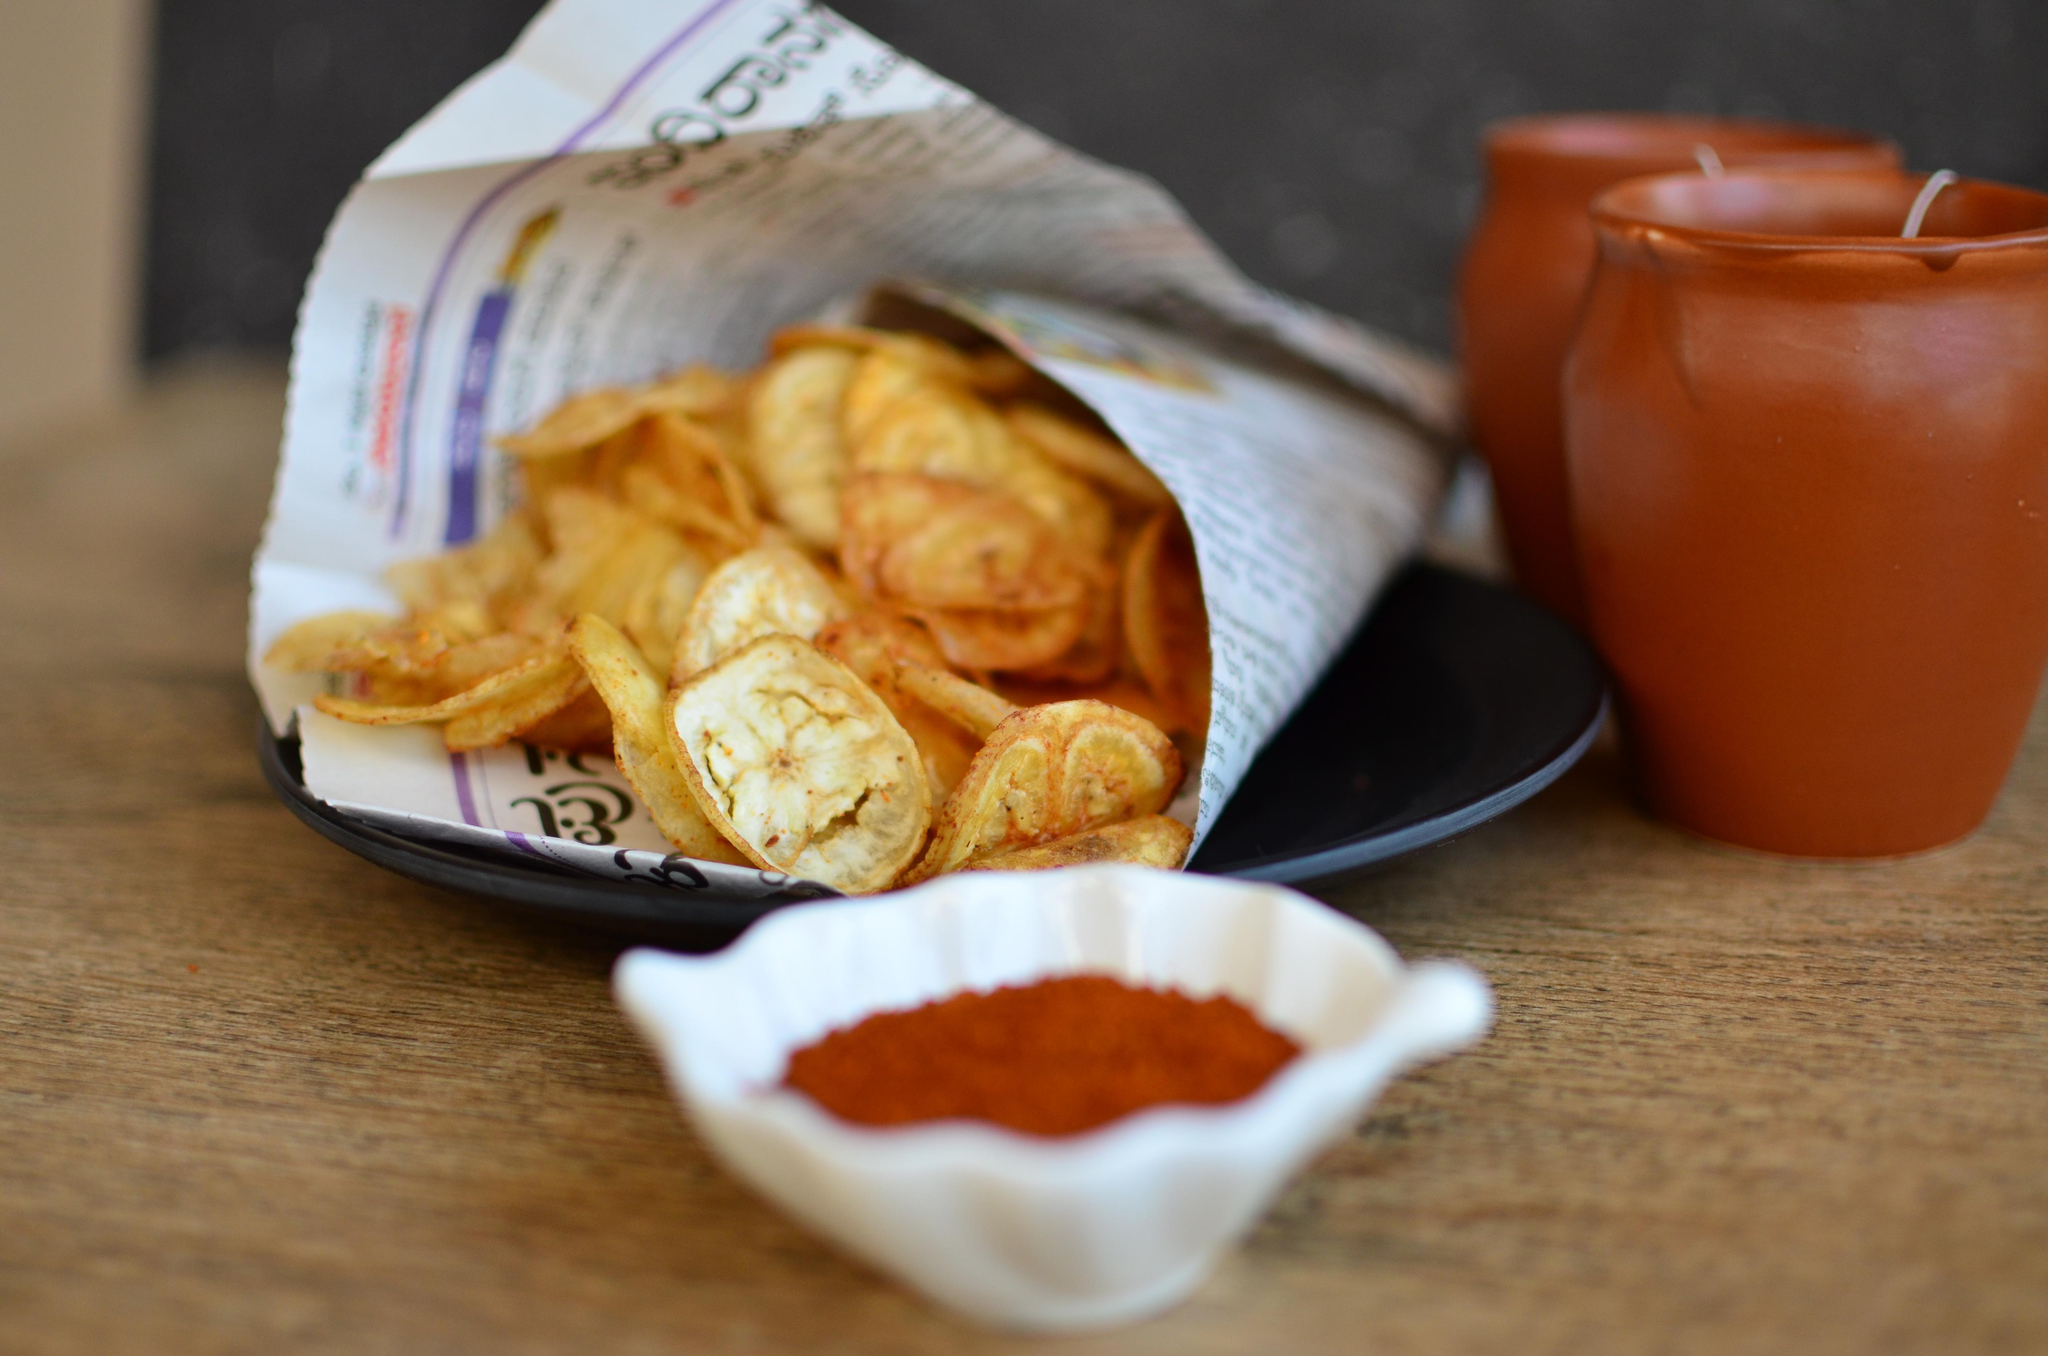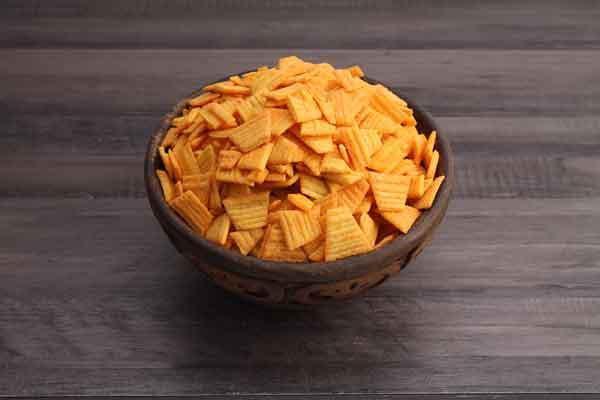The first image is the image on the left, the second image is the image on the right. For the images shown, is this caption "The left image shows a fried treat served on a dark plate, with something in a smaller bowl nearby." true? Answer yes or no. Yes. The first image is the image on the left, the second image is the image on the right. Examine the images to the left and right. Is the description "The chips in the image on the left are served with a side of red dipping sauce." accurate? Answer yes or no. Yes. 